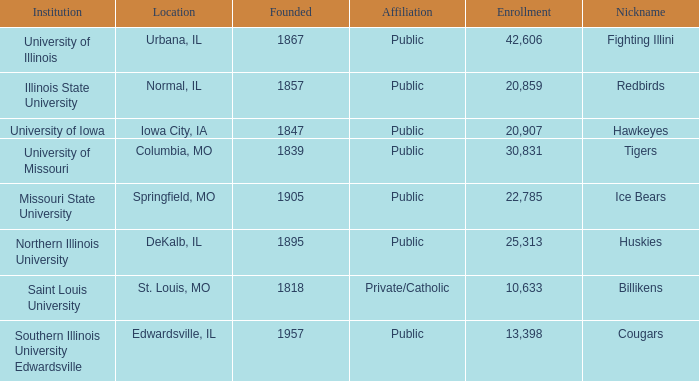Which establishment is private and catholic? Saint Louis University. 